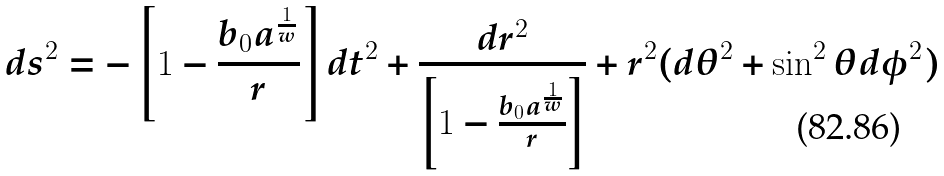<formula> <loc_0><loc_0><loc_500><loc_500>d s ^ { 2 } = - \left [ 1 - \frac { b _ { 0 } a ^ { \frac { 1 } { w } } } { r } \right ] d t ^ { 2 } + \frac { d r ^ { 2 } } { \left [ 1 - \frac { b _ { 0 } a ^ { \frac { 1 } { w } } } { r } \right ] } + r ^ { 2 } ( d \theta ^ { 2 } + \sin ^ { 2 } \theta d \phi ^ { 2 } )</formula> 